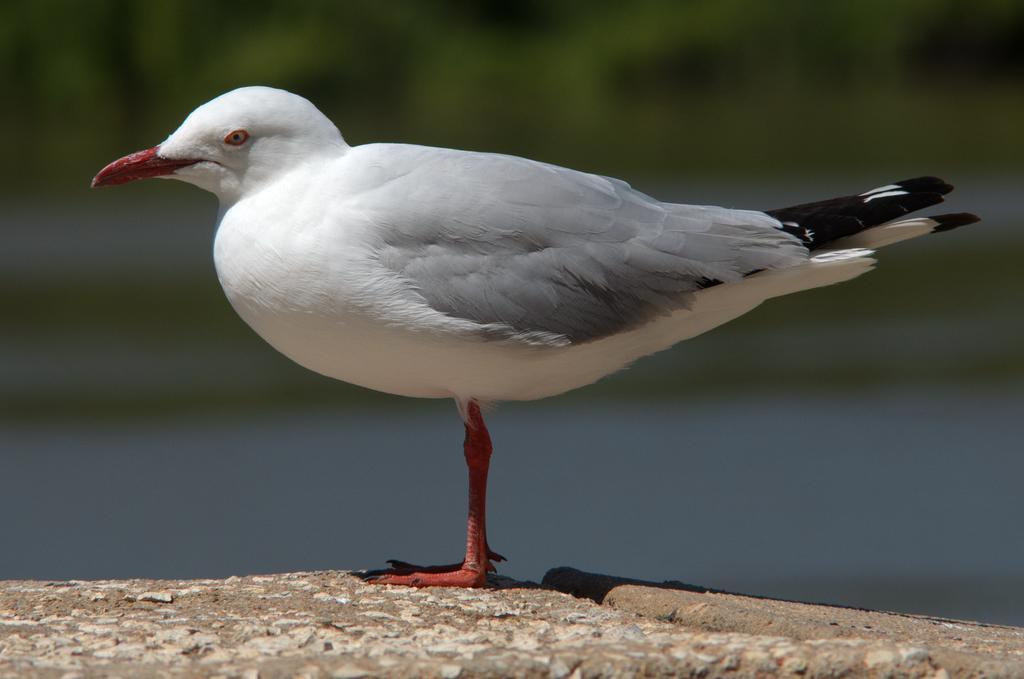Please provide a concise description of this image. In this image I can see a bird which is white, ash, black and red in color is standing on the ground. In the backhand I can see few trees and few other blurry objects. 